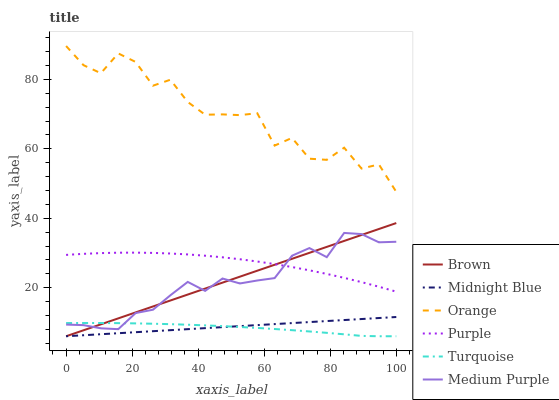Does Turquoise have the minimum area under the curve?
Answer yes or no. Yes. Does Orange have the maximum area under the curve?
Answer yes or no. Yes. Does Midnight Blue have the minimum area under the curve?
Answer yes or no. No. Does Midnight Blue have the maximum area under the curve?
Answer yes or no. No. Is Midnight Blue the smoothest?
Answer yes or no. Yes. Is Orange the roughest?
Answer yes or no. Yes. Is Turquoise the smoothest?
Answer yes or no. No. Is Turquoise the roughest?
Answer yes or no. No. Does Brown have the lowest value?
Answer yes or no. Yes. Does Purple have the lowest value?
Answer yes or no. No. Does Orange have the highest value?
Answer yes or no. Yes. Does Midnight Blue have the highest value?
Answer yes or no. No. Is Turquoise less than Purple?
Answer yes or no. Yes. Is Purple greater than Turquoise?
Answer yes or no. Yes. Does Midnight Blue intersect Turquoise?
Answer yes or no. Yes. Is Midnight Blue less than Turquoise?
Answer yes or no. No. Is Midnight Blue greater than Turquoise?
Answer yes or no. No. Does Turquoise intersect Purple?
Answer yes or no. No. 